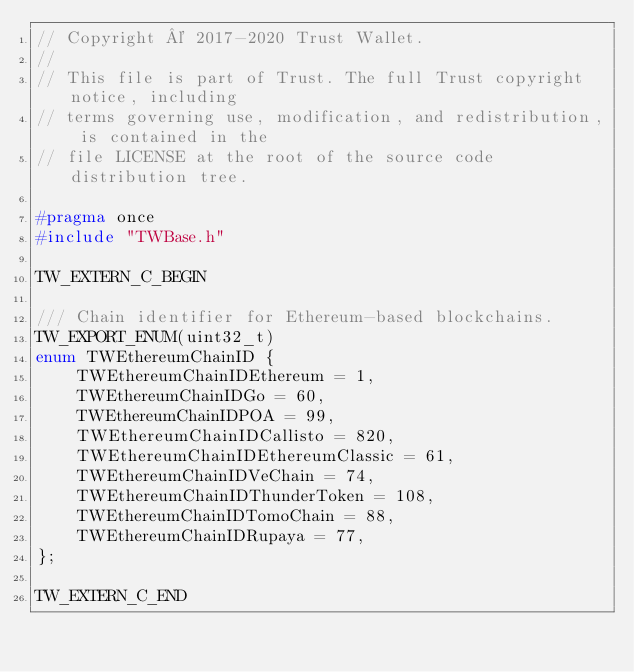Convert code to text. <code><loc_0><loc_0><loc_500><loc_500><_C_>// Copyright © 2017-2020 Trust Wallet.
//
// This file is part of Trust. The full Trust copyright notice, including
// terms governing use, modification, and redistribution, is contained in the
// file LICENSE at the root of the source code distribution tree.

#pragma once
#include "TWBase.h"

TW_EXTERN_C_BEGIN

/// Chain identifier for Ethereum-based blockchains.
TW_EXPORT_ENUM(uint32_t)
enum TWEthereumChainID {
    TWEthereumChainIDEthereum = 1,
    TWEthereumChainIDGo = 60,
    TWEthereumChainIDPOA = 99,
    TWEthereumChainIDCallisto = 820,
    TWEthereumChainIDEthereumClassic = 61,
    TWEthereumChainIDVeChain = 74,
    TWEthereumChainIDThunderToken = 108,
    TWEthereumChainIDTomoChain = 88,
    TWEthereumChainIDRupaya = 77,
};

TW_EXTERN_C_END
</code> 